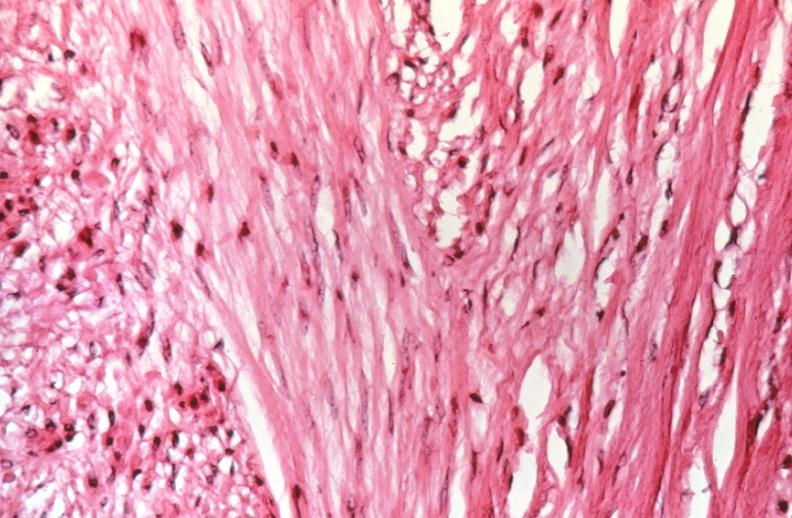where is this from?
Answer the question using a single word or phrase. Female reproductive system 